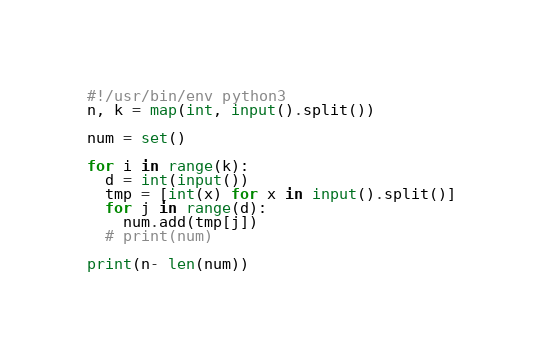Convert code to text. <code><loc_0><loc_0><loc_500><loc_500><_Python_>#!/usr/bin/env python3
n, k = map(int, input().split())

num = set()

for i in range(k):
  d = int(input())
  tmp = [int(x) for x in input().split()]
  for j in range(d):
    num.add(tmp[j])
  # print(num)

print(n- len(num))</code> 